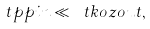Convert formula to latex. <formula><loc_0><loc_0><loc_500><loc_500>\ t p p i n \ll \ t k o z o u t ,</formula> 